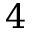Convert formula to latex. <formula><loc_0><loc_0><loc_500><loc_500>4</formula> 